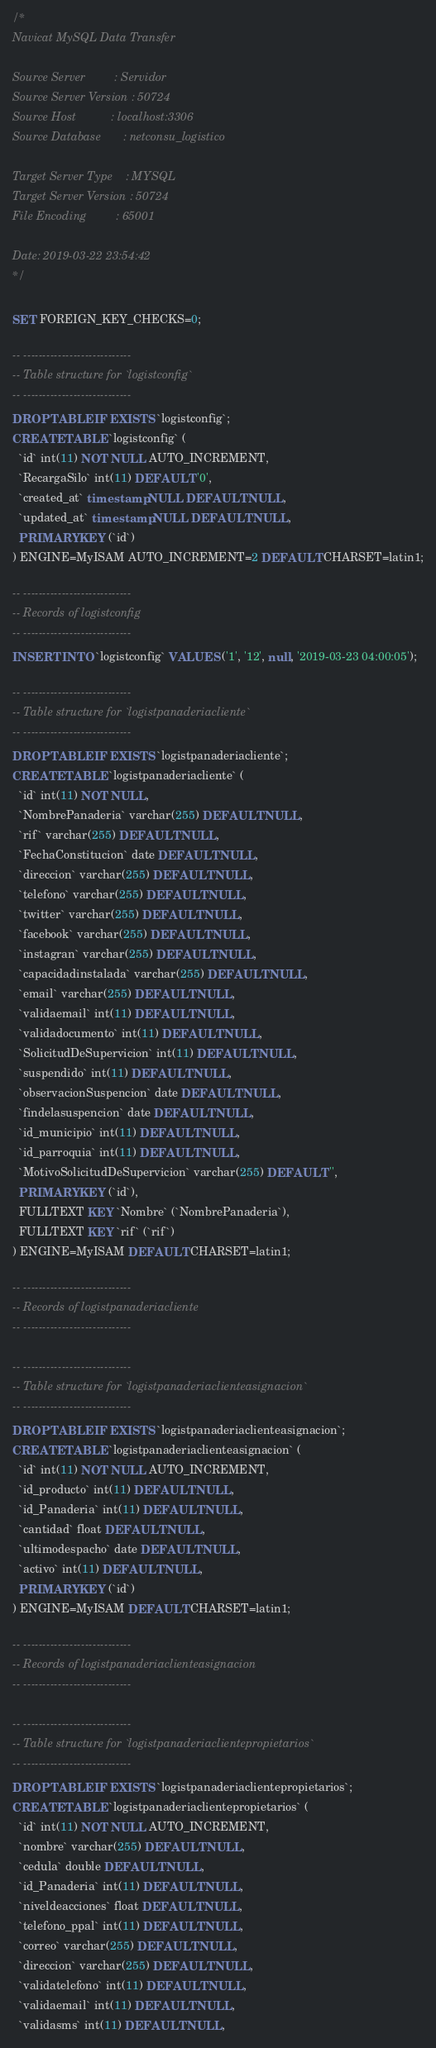Convert code to text. <code><loc_0><loc_0><loc_500><loc_500><_SQL_>/*
Navicat MySQL Data Transfer

Source Server         : Servidor
Source Server Version : 50724
Source Host           : localhost:3306
Source Database       : netconsu_logistico

Target Server Type    : MYSQL
Target Server Version : 50724
File Encoding         : 65001

Date: 2019-03-22 23:54:42
*/

SET FOREIGN_KEY_CHECKS=0;

-- ----------------------------
-- Table structure for `logistconfig`
-- ----------------------------
DROP TABLE IF EXISTS `logistconfig`;
CREATE TABLE `logistconfig` (
  `id` int(11) NOT NULL AUTO_INCREMENT,
  `RecargaSilo` int(11) DEFAULT '0',
  `created_at` timestamp NULL DEFAULT NULL,
  `updated_at` timestamp NULL DEFAULT NULL,
  PRIMARY KEY (`id`)
) ENGINE=MyISAM AUTO_INCREMENT=2 DEFAULT CHARSET=latin1;

-- ----------------------------
-- Records of logistconfig
-- ----------------------------
INSERT INTO `logistconfig` VALUES ('1', '12', null, '2019-03-23 04:00:05');

-- ----------------------------
-- Table structure for `logistpanaderiacliente`
-- ----------------------------
DROP TABLE IF EXISTS `logistpanaderiacliente`;
CREATE TABLE `logistpanaderiacliente` (
  `id` int(11) NOT NULL,
  `NombrePanaderia` varchar(255) DEFAULT NULL,
  `rif` varchar(255) DEFAULT NULL,
  `FechaConstitucion` date DEFAULT NULL,
  `direccion` varchar(255) DEFAULT NULL,
  `telefono` varchar(255) DEFAULT NULL,
  `twitter` varchar(255) DEFAULT NULL,
  `facebook` varchar(255) DEFAULT NULL,
  `instagran` varchar(255) DEFAULT NULL,
  `capacidadinstalada` varchar(255) DEFAULT NULL,
  `email` varchar(255) DEFAULT NULL,
  `validaemail` int(11) DEFAULT NULL,
  `validadocumento` int(11) DEFAULT NULL,
  `SolicitudDeSupervicion` int(11) DEFAULT NULL,
  `suspendido` int(11) DEFAULT NULL,
  `observacionSuspencion` date DEFAULT NULL,
  `findelasuspencion` date DEFAULT NULL,
  `id_municipio` int(11) DEFAULT NULL,
  `id_parroquia` int(11) DEFAULT NULL,
  `MotivoSolicitudDeSupervicion` varchar(255) DEFAULT '',
  PRIMARY KEY (`id`),
  FULLTEXT KEY `Nombre` (`NombrePanaderia`),
  FULLTEXT KEY `rif` (`rif`)
) ENGINE=MyISAM DEFAULT CHARSET=latin1;

-- ----------------------------
-- Records of logistpanaderiacliente
-- ----------------------------

-- ----------------------------
-- Table structure for `logistpanaderiaclienteasignacion`
-- ----------------------------
DROP TABLE IF EXISTS `logistpanaderiaclienteasignacion`;
CREATE TABLE `logistpanaderiaclienteasignacion` (
  `id` int(11) NOT NULL AUTO_INCREMENT,
  `id_producto` int(11) DEFAULT NULL,
  `id_Panaderia` int(11) DEFAULT NULL,
  `cantidad` float DEFAULT NULL,
  `ultimodespacho` date DEFAULT NULL,
  `activo` int(11) DEFAULT NULL,
  PRIMARY KEY (`id`)
) ENGINE=MyISAM DEFAULT CHARSET=latin1;

-- ----------------------------
-- Records of logistpanaderiaclienteasignacion
-- ----------------------------

-- ----------------------------
-- Table structure for `logistpanaderiaclientepropietarios`
-- ----------------------------
DROP TABLE IF EXISTS `logistpanaderiaclientepropietarios`;
CREATE TABLE `logistpanaderiaclientepropietarios` (
  `id` int(11) NOT NULL AUTO_INCREMENT,
  `nombre` varchar(255) DEFAULT NULL,
  `cedula` double DEFAULT NULL,
  `id_Panaderia` int(11) DEFAULT NULL,
  `niveldeacciones` float DEFAULT NULL,
  `telefono_ppal` int(11) DEFAULT NULL,
  `correo` varchar(255) DEFAULT NULL,
  `direccion` varchar(255) DEFAULT NULL,
  `validatelefono` int(11) DEFAULT NULL,
  `validaemail` int(11) DEFAULT NULL,
  `validasms` int(11) DEFAULT NULL,</code> 